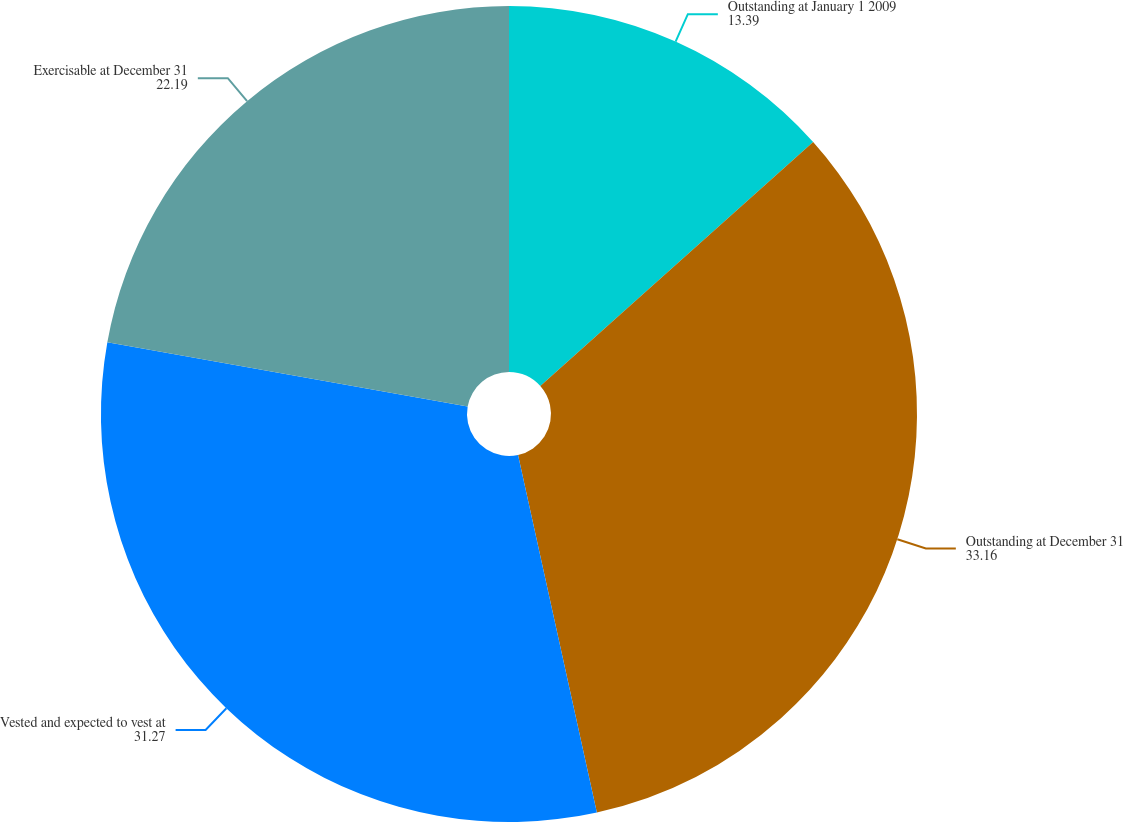<chart> <loc_0><loc_0><loc_500><loc_500><pie_chart><fcel>Outstanding at January 1 2009<fcel>Outstanding at December 31<fcel>Vested and expected to vest at<fcel>Exercisable at December 31<nl><fcel>13.39%<fcel>33.16%<fcel>31.27%<fcel>22.19%<nl></chart> 